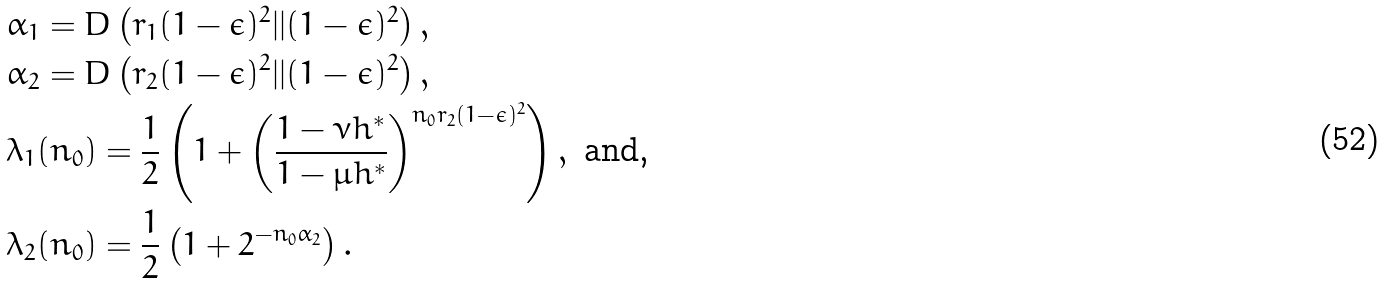<formula> <loc_0><loc_0><loc_500><loc_500>& \alpha _ { 1 } = D \left ( r _ { 1 } ( 1 - \epsilon ) ^ { 2 } | | ( 1 - \epsilon ) ^ { 2 } \right ) , \\ & \alpha _ { 2 } = D \left ( r _ { 2 } ( 1 - \epsilon ) ^ { 2 } | | ( 1 - \epsilon ) ^ { 2 } \right ) , \\ & \lambda _ { 1 } ( n _ { 0 } ) = \frac { 1 } { 2 } \left ( 1 + \left ( \frac { 1 - \nu h ^ { \ast } } { 1 - \mu h ^ { \ast } } \right ) ^ { n _ { 0 } r _ { 2 } ( 1 - \epsilon ) ^ { 2 } } \right ) , \text { and,} \\ & \lambda _ { 2 } ( n _ { 0 } ) = \frac { 1 } { 2 } \left ( 1 + 2 ^ { - n _ { 0 } \alpha _ { 2 } } \right ) .</formula> 